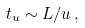<formula> <loc_0><loc_0><loc_500><loc_500>t _ { u } \sim L / u \, ,</formula> 